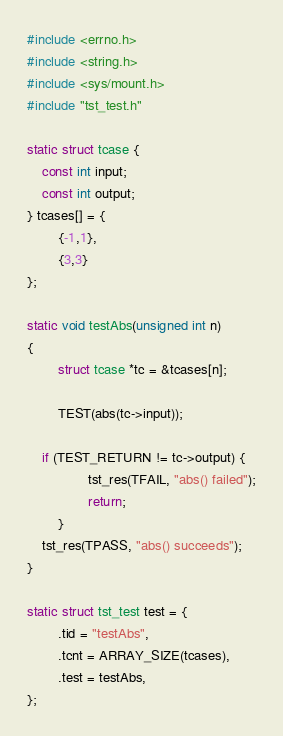<code> <loc_0><loc_0><loc_500><loc_500><_C_>#include <errno.h>
#include <string.h>
#include <sys/mount.h>
#include "tst_test.h"

static struct tcase {
	const int input;
	const int output;
} tcases[] = {
        {-1,1},
        {3,3}
};

static void testAbs(unsigned int n)
{
        struct tcase *tc = &tcases[n];

        TEST(abs(tc->input));
       
	if (TEST_RETURN != tc->output) {
                tst_res(TFAIL, "abs() failed");
                return;
        }
	tst_res(TPASS, "abs() succeeds");
}

static struct tst_test test = {
        .tid = "testAbs",
        .tcnt = ARRAY_SIZE(tcases),
        .test = testAbs,
};
</code> 